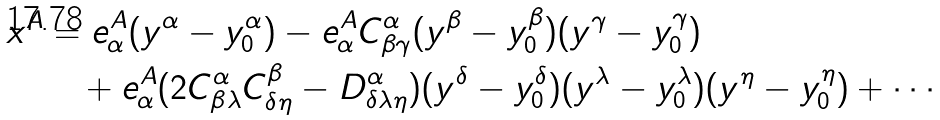<formula> <loc_0><loc_0><loc_500><loc_500>x ^ { A } & = e ^ { A } _ { \alpha } ( y ^ { \alpha } - y ^ { \alpha } _ { 0 } ) - e ^ { A } _ { \alpha } C _ { \beta \gamma } ^ { \alpha } ( y ^ { \beta } - y ^ { \beta } _ { 0 } ) ( y ^ { \gamma } - y ^ { \gamma } _ { 0 } ) \\ & \quad + e ^ { A } _ { \alpha } ( 2 C _ { \beta \lambda } ^ { \alpha } C _ { \delta \eta } ^ { \beta } - D _ { \delta \lambda \eta } ^ { \alpha } ) ( y ^ { \delta } - y ^ { \delta } _ { 0 } ) ( y ^ { \lambda } - y ^ { \lambda } _ { 0 } ) ( y ^ { \eta } - y ^ { \eta } _ { 0 } ) + \cdots</formula> 